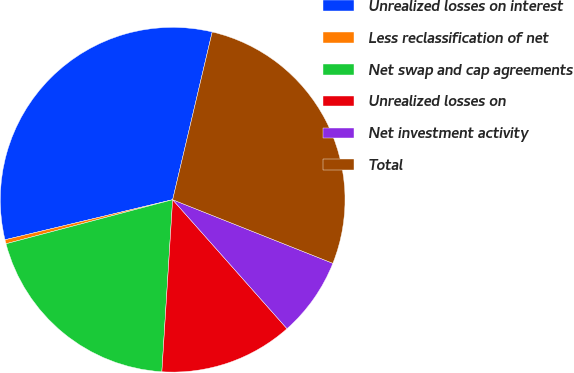Convert chart to OTSL. <chart><loc_0><loc_0><loc_500><loc_500><pie_chart><fcel>Unrealized losses on interest<fcel>Less reclassification of net<fcel>Net swap and cap agreements<fcel>Unrealized losses on<fcel>Net investment activity<fcel>Total<nl><fcel>32.42%<fcel>0.38%<fcel>19.89%<fcel>12.54%<fcel>7.44%<fcel>27.33%<nl></chart> 